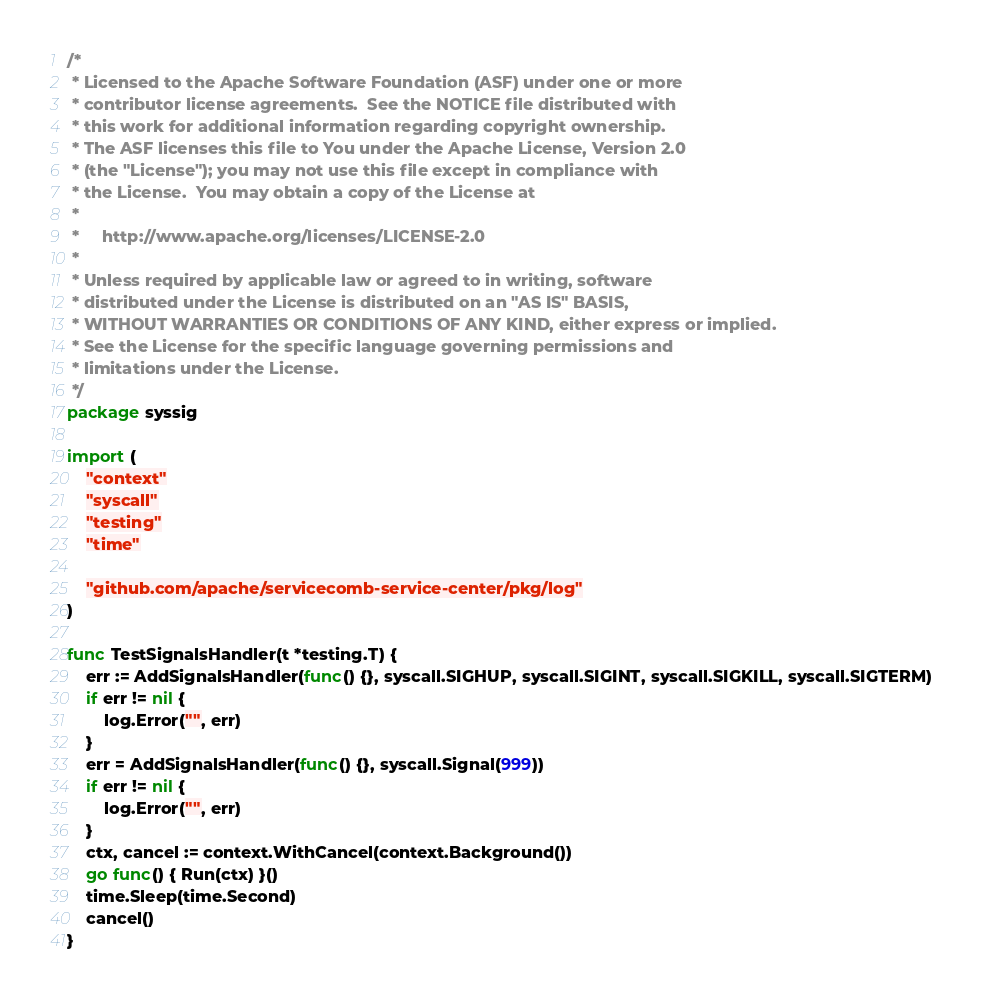Convert code to text. <code><loc_0><loc_0><loc_500><loc_500><_Go_>/*
 * Licensed to the Apache Software Foundation (ASF) under one or more
 * contributor license agreements.  See the NOTICE file distributed with
 * this work for additional information regarding copyright ownership.
 * The ASF licenses this file to You under the Apache License, Version 2.0
 * (the "License"); you may not use this file except in compliance with
 * the License.  You may obtain a copy of the License at
 *
 *     http://www.apache.org/licenses/LICENSE-2.0
 *
 * Unless required by applicable law or agreed to in writing, software
 * distributed under the License is distributed on an "AS IS" BASIS,
 * WITHOUT WARRANTIES OR CONDITIONS OF ANY KIND, either express or implied.
 * See the License for the specific language governing permissions and
 * limitations under the License.
 */
package syssig

import (
	"context"
	"syscall"
	"testing"
	"time"

	"github.com/apache/servicecomb-service-center/pkg/log"
)

func TestSignalsHandler(t *testing.T) {
	err := AddSignalsHandler(func() {}, syscall.SIGHUP, syscall.SIGINT, syscall.SIGKILL, syscall.SIGTERM)
	if err != nil {
		log.Error("", err)
	}
	err = AddSignalsHandler(func() {}, syscall.Signal(999))
	if err != nil {
		log.Error("", err)
	}
	ctx, cancel := context.WithCancel(context.Background())
	go func() { Run(ctx) }()
	time.Sleep(time.Second)
	cancel()
}
</code> 